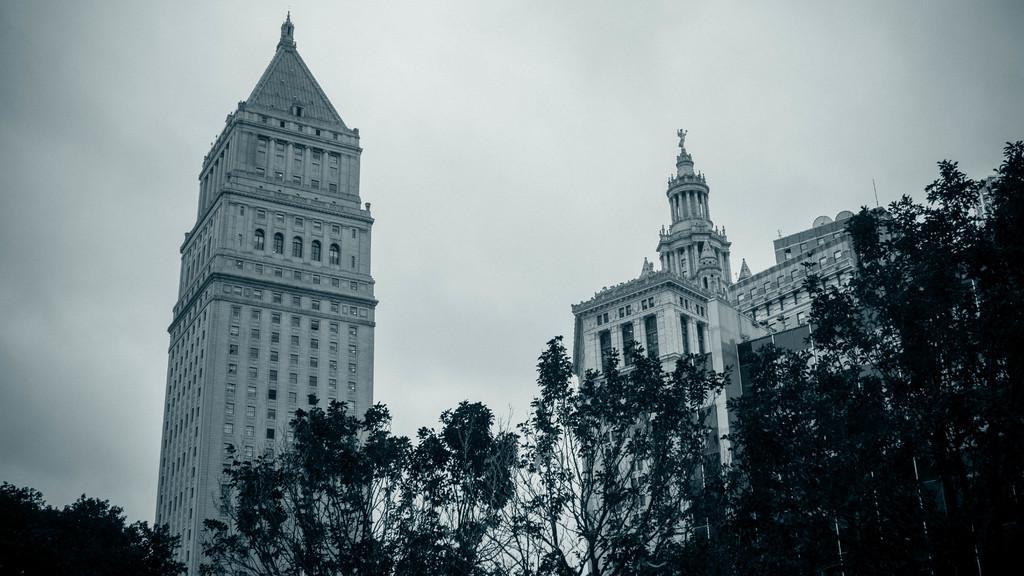Can you describe this image briefly? In this image I can see trees in green color, background I can see few buildings in white color and the sky is in white color. 